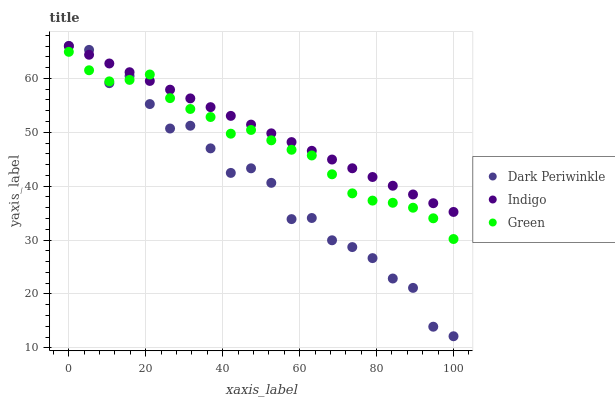Does Dark Periwinkle have the minimum area under the curve?
Answer yes or no. Yes. Does Indigo have the maximum area under the curve?
Answer yes or no. Yes. Does Indigo have the minimum area under the curve?
Answer yes or no. No. Does Dark Periwinkle have the maximum area under the curve?
Answer yes or no. No. Is Indigo the smoothest?
Answer yes or no. Yes. Is Dark Periwinkle the roughest?
Answer yes or no. Yes. Is Dark Periwinkle the smoothest?
Answer yes or no. No. Is Indigo the roughest?
Answer yes or no. No. Does Dark Periwinkle have the lowest value?
Answer yes or no. Yes. Does Indigo have the lowest value?
Answer yes or no. No. Does Dark Periwinkle have the highest value?
Answer yes or no. Yes. Does Dark Periwinkle intersect Indigo?
Answer yes or no. Yes. Is Dark Periwinkle less than Indigo?
Answer yes or no. No. Is Dark Periwinkle greater than Indigo?
Answer yes or no. No. 